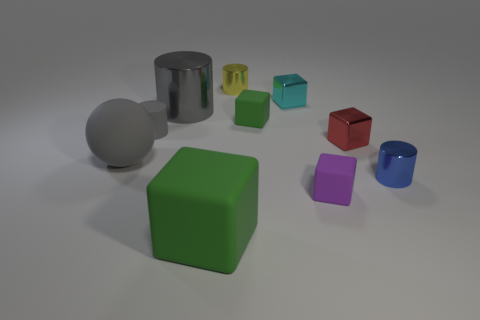Does the large cylinder have the same color as the large ball?
Give a very brief answer. Yes. Do the shiny cylinder that is in front of the matte sphere and the metal object on the left side of the large green object have the same size?
Provide a short and direct response. No. How many gray objects are made of the same material as the tiny gray cylinder?
Keep it short and to the point. 1. There is a cylinder in front of the tiny cylinder that is left of the large green rubber cube; how many big gray objects are behind it?
Ensure brevity in your answer.  2. Is the shape of the big shiny object the same as the cyan metallic thing?
Offer a terse response. No. Is there a large brown rubber object that has the same shape as the big green matte thing?
Offer a very short reply. No. The green matte thing that is the same size as the gray rubber cylinder is what shape?
Offer a very short reply. Cube. There is a tiny cylinder that is behind the block behind the small green matte thing that is to the left of the tiny purple rubber cube; what is it made of?
Keep it short and to the point. Metal. Do the yellow cylinder and the blue metal cylinder have the same size?
Your answer should be very brief. Yes. What is the material of the big green object?
Provide a succinct answer. Rubber. 